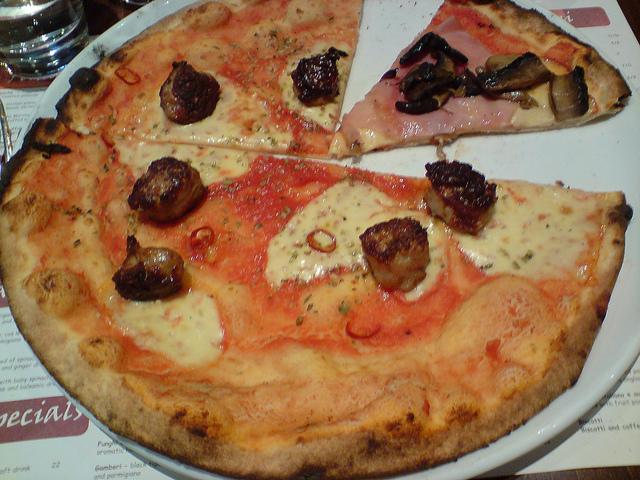How many slices is this pizza divided into?
Write a very short answer. 3. Is any of the pizza gone?
Concise answer only. Yes. Are the slices equal in size?
Be succinct. No. What is the black topping?
Concise answer only. Sausage. Is the pizza oven?
Concise answer only. No. What meat topping is shown on the food item?
Give a very brief answer. Sausage. Does the pizza have shrimp?
Write a very short answer. No. What do you call this dish?
Short answer required. Pizza. What are the black vegetables on the pizza called?
Answer briefly. Mushrooms. What kind of cheese is on this pizza?
Quick response, please. Mozzarella. Does the pizza have enough cheese?
Give a very brief answer. No. How many slices are missing?
Concise answer only. 1. Is there any ham on the pizza?
Short answer required. Yes. 